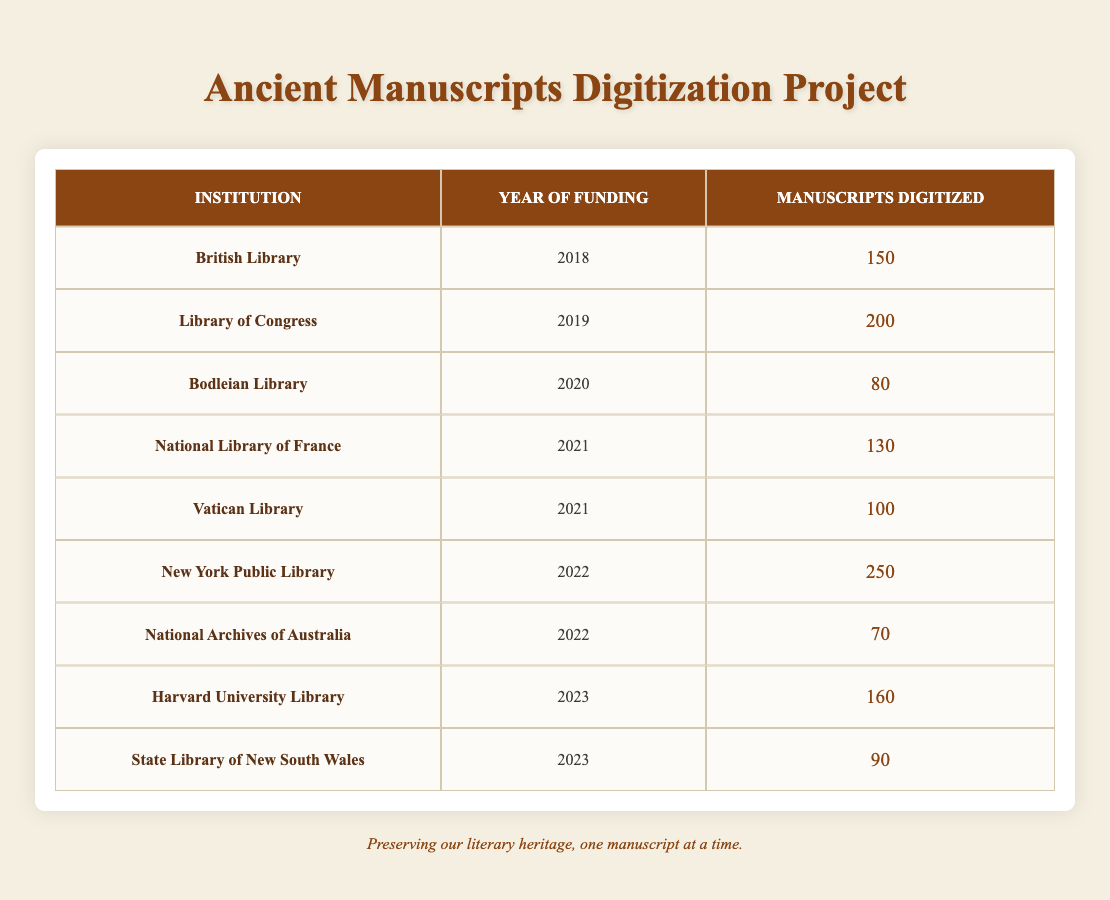What institution digitized the most manuscripts in a single year? Looking at the table, the New York Public Library in 2022 digitized the highest number of manuscripts at 250.
Answer: New York Public Library In what year did the Bodleian Library receive funding for digitization? The table shows that the Bodleian Library received funding in 2020 for digitization.
Answer: 2020 How many manuscripts were digitized by the Vatican Library and the National Library of France combined? The Vatican Library digitized 100 manuscripts and the National Library of France digitized 130 manuscripts. Adding them together gives 100 + 130 = 230.
Answer: 230 Is it true that more manuscripts were digitized in 2022 than in 2021? In 2022, 250 (New York Public Library) + 70 (National Archives of Australia) = 320 manuscripts were digitized. In 2021, 130 (National Library of France) + 100 (Vatican Library) = 230 manuscripts were digitized. Since 320 > 230, the statement is true.
Answer: Yes What is the average number of manuscripts digitized per year from 2018 to 2023? The numbers of manuscripts digitized per year are: 150 (2018), 200 (2019), 80 (2020), 130 (2021), 100 (2021), 250 (2022), 70 (2022), 160 (2023), and 90 (2023). Adding these gives 1,080 manuscripts in total. There are 6 years (2018, 2019, 2020, 2021, 2022, 2023), so the average is 1,080 / 6 = 180.
Answer: 180 Which institution digitized the least amount of manuscripts and how many? The table shows that the National Archives of Australia digitized the least with 70 manuscripts in 2022.
Answer: National Archives of Australia, 70 